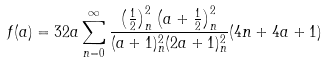Convert formula to latex. <formula><loc_0><loc_0><loc_500><loc_500>f ( a ) = 3 2 a \sum _ { n = 0 } ^ { \infty } \frac { \left ( \frac { 1 } { 2 } \right ) _ { n } ^ { 2 } \left ( a + \frac { 1 } { 2 } \right ) _ { n } ^ { 2 } } { ( a + 1 ) _ { n } ^ { 2 } ( 2 a + 1 ) _ { n } ^ { 2 } } ( 4 n + 4 a + 1 )</formula> 